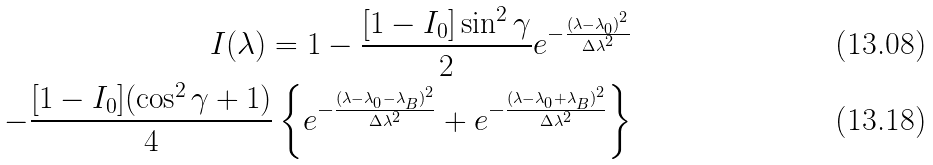<formula> <loc_0><loc_0><loc_500><loc_500>I ( \lambda ) = 1 - \frac { [ 1 - I _ { 0 } ] \sin ^ { 2 } \gamma } { 2 } e ^ { - \frac { ( \lambda - \lambda _ { 0 } ) ^ { 2 } } { \Delta \lambda ^ { 2 } } } \\ - \frac { [ 1 - I _ { 0 } ] ( \cos ^ { 2 } \gamma + 1 ) } { 4 } \left \{ e ^ { - \frac { ( \lambda - \lambda _ { 0 } - \lambda _ { B } ) ^ { 2 } } { \Delta \lambda ^ { 2 } } } + e ^ { - \frac { ( \lambda - \lambda _ { 0 } + \lambda _ { B } ) ^ { 2 } } { \Delta \lambda ^ { 2 } } } \right \}</formula> 